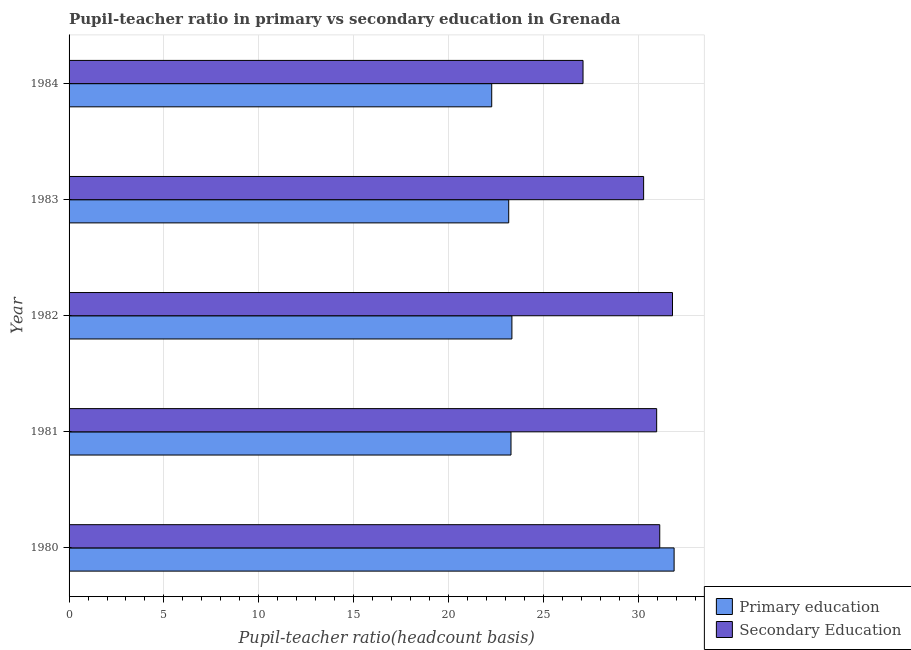Are the number of bars per tick equal to the number of legend labels?
Offer a very short reply. Yes. Are the number of bars on each tick of the Y-axis equal?
Offer a terse response. Yes. In how many cases, is the number of bars for a given year not equal to the number of legend labels?
Provide a short and direct response. 0. What is the pupil-teacher ratio in primary education in 1982?
Ensure brevity in your answer.  23.34. Across all years, what is the maximum pupil teacher ratio on secondary education?
Keep it short and to the point. 31.81. Across all years, what is the minimum pupil teacher ratio on secondary education?
Provide a short and direct response. 27.09. In which year was the pupil-teacher ratio in primary education minimum?
Provide a succinct answer. 1984. What is the total pupil teacher ratio on secondary education in the graph?
Your answer should be very brief. 151.29. What is the difference between the pupil-teacher ratio in primary education in 1983 and that in 1984?
Your answer should be very brief. 0.9. What is the difference between the pupil-teacher ratio in primary education in 1984 and the pupil teacher ratio on secondary education in 1983?
Your answer should be compact. -8.01. What is the average pupil teacher ratio on secondary education per year?
Give a very brief answer. 30.26. In the year 1984, what is the difference between the pupil teacher ratio on secondary education and pupil-teacher ratio in primary education?
Provide a short and direct response. 4.81. What is the ratio of the pupil teacher ratio on secondary education in 1982 to that in 1984?
Make the answer very short. 1.17. Is the pupil-teacher ratio in primary education in 1982 less than that in 1983?
Your answer should be very brief. No. What is the difference between the highest and the second highest pupil teacher ratio on secondary education?
Your answer should be compact. 0.67. What is the difference between the highest and the lowest pupil-teacher ratio in primary education?
Your answer should be compact. 9.61. In how many years, is the pupil teacher ratio on secondary education greater than the average pupil teacher ratio on secondary education taken over all years?
Ensure brevity in your answer.  4. What does the 2nd bar from the top in 1983 represents?
Give a very brief answer. Primary education. How many bars are there?
Your answer should be very brief. 10. Are all the bars in the graph horizontal?
Your response must be concise. Yes. How many years are there in the graph?
Provide a short and direct response. 5. What is the difference between two consecutive major ticks on the X-axis?
Offer a terse response. 5. Are the values on the major ticks of X-axis written in scientific E-notation?
Provide a short and direct response. No. Does the graph contain any zero values?
Ensure brevity in your answer.  No. Does the graph contain grids?
Your response must be concise. Yes. Where does the legend appear in the graph?
Provide a short and direct response. Bottom right. How many legend labels are there?
Make the answer very short. 2. What is the title of the graph?
Provide a short and direct response. Pupil-teacher ratio in primary vs secondary education in Grenada. What is the label or title of the X-axis?
Provide a short and direct response. Pupil-teacher ratio(headcount basis). What is the label or title of the Y-axis?
Make the answer very short. Year. What is the Pupil-teacher ratio(headcount basis) in Primary education in 1980?
Your answer should be very brief. 31.89. What is the Pupil-teacher ratio(headcount basis) in Secondary Education in 1980?
Your answer should be compact. 31.13. What is the Pupil-teacher ratio(headcount basis) of Primary education in 1981?
Provide a short and direct response. 23.29. What is the Pupil-teacher ratio(headcount basis) in Secondary Education in 1981?
Your response must be concise. 30.97. What is the Pupil-teacher ratio(headcount basis) in Primary education in 1982?
Offer a terse response. 23.34. What is the Pupil-teacher ratio(headcount basis) of Secondary Education in 1982?
Ensure brevity in your answer.  31.81. What is the Pupil-teacher ratio(headcount basis) in Primary education in 1983?
Give a very brief answer. 23.17. What is the Pupil-teacher ratio(headcount basis) of Secondary Education in 1983?
Your answer should be compact. 30.28. What is the Pupil-teacher ratio(headcount basis) in Primary education in 1984?
Ensure brevity in your answer.  22.28. What is the Pupil-teacher ratio(headcount basis) of Secondary Education in 1984?
Offer a very short reply. 27.09. Across all years, what is the maximum Pupil-teacher ratio(headcount basis) in Primary education?
Give a very brief answer. 31.89. Across all years, what is the maximum Pupil-teacher ratio(headcount basis) in Secondary Education?
Offer a terse response. 31.81. Across all years, what is the minimum Pupil-teacher ratio(headcount basis) in Primary education?
Offer a very short reply. 22.28. Across all years, what is the minimum Pupil-teacher ratio(headcount basis) in Secondary Education?
Provide a succinct answer. 27.09. What is the total Pupil-teacher ratio(headcount basis) in Primary education in the graph?
Provide a succinct answer. 123.98. What is the total Pupil-teacher ratio(headcount basis) of Secondary Education in the graph?
Your answer should be very brief. 151.29. What is the difference between the Pupil-teacher ratio(headcount basis) in Primary education in 1980 and that in 1981?
Give a very brief answer. 8.6. What is the difference between the Pupil-teacher ratio(headcount basis) in Secondary Education in 1980 and that in 1981?
Keep it short and to the point. 0.16. What is the difference between the Pupil-teacher ratio(headcount basis) in Primary education in 1980 and that in 1982?
Your response must be concise. 8.55. What is the difference between the Pupil-teacher ratio(headcount basis) of Secondary Education in 1980 and that in 1982?
Offer a very short reply. -0.67. What is the difference between the Pupil-teacher ratio(headcount basis) in Primary education in 1980 and that in 1983?
Make the answer very short. 8.72. What is the difference between the Pupil-teacher ratio(headcount basis) in Secondary Education in 1980 and that in 1983?
Offer a very short reply. 0.85. What is the difference between the Pupil-teacher ratio(headcount basis) in Primary education in 1980 and that in 1984?
Your answer should be compact. 9.61. What is the difference between the Pupil-teacher ratio(headcount basis) of Secondary Education in 1980 and that in 1984?
Offer a very short reply. 4.04. What is the difference between the Pupil-teacher ratio(headcount basis) of Primary education in 1981 and that in 1982?
Keep it short and to the point. -0.05. What is the difference between the Pupil-teacher ratio(headcount basis) in Secondary Education in 1981 and that in 1982?
Make the answer very short. -0.83. What is the difference between the Pupil-teacher ratio(headcount basis) of Primary education in 1981 and that in 1983?
Provide a short and direct response. 0.12. What is the difference between the Pupil-teacher ratio(headcount basis) in Secondary Education in 1981 and that in 1983?
Offer a terse response. 0.69. What is the difference between the Pupil-teacher ratio(headcount basis) in Primary education in 1981 and that in 1984?
Offer a terse response. 1.02. What is the difference between the Pupil-teacher ratio(headcount basis) in Secondary Education in 1981 and that in 1984?
Offer a very short reply. 3.88. What is the difference between the Pupil-teacher ratio(headcount basis) of Primary education in 1982 and that in 1983?
Your response must be concise. 0.17. What is the difference between the Pupil-teacher ratio(headcount basis) of Secondary Education in 1982 and that in 1983?
Your answer should be compact. 1.52. What is the difference between the Pupil-teacher ratio(headcount basis) of Primary education in 1982 and that in 1984?
Provide a short and direct response. 1.06. What is the difference between the Pupil-teacher ratio(headcount basis) in Secondary Education in 1982 and that in 1984?
Your answer should be very brief. 4.72. What is the difference between the Pupil-teacher ratio(headcount basis) of Primary education in 1983 and that in 1984?
Offer a terse response. 0.9. What is the difference between the Pupil-teacher ratio(headcount basis) in Secondary Education in 1983 and that in 1984?
Offer a very short reply. 3.19. What is the difference between the Pupil-teacher ratio(headcount basis) in Primary education in 1980 and the Pupil-teacher ratio(headcount basis) in Secondary Education in 1981?
Make the answer very short. 0.92. What is the difference between the Pupil-teacher ratio(headcount basis) of Primary education in 1980 and the Pupil-teacher ratio(headcount basis) of Secondary Education in 1982?
Offer a very short reply. 0.09. What is the difference between the Pupil-teacher ratio(headcount basis) in Primary education in 1980 and the Pupil-teacher ratio(headcount basis) in Secondary Education in 1983?
Your answer should be compact. 1.61. What is the difference between the Pupil-teacher ratio(headcount basis) of Primary education in 1980 and the Pupil-teacher ratio(headcount basis) of Secondary Education in 1984?
Keep it short and to the point. 4.8. What is the difference between the Pupil-teacher ratio(headcount basis) of Primary education in 1981 and the Pupil-teacher ratio(headcount basis) of Secondary Education in 1982?
Provide a short and direct response. -8.51. What is the difference between the Pupil-teacher ratio(headcount basis) in Primary education in 1981 and the Pupil-teacher ratio(headcount basis) in Secondary Education in 1983?
Your answer should be very brief. -6.99. What is the difference between the Pupil-teacher ratio(headcount basis) in Primary education in 1981 and the Pupil-teacher ratio(headcount basis) in Secondary Education in 1984?
Your response must be concise. -3.8. What is the difference between the Pupil-teacher ratio(headcount basis) in Primary education in 1982 and the Pupil-teacher ratio(headcount basis) in Secondary Education in 1983?
Keep it short and to the point. -6.94. What is the difference between the Pupil-teacher ratio(headcount basis) in Primary education in 1982 and the Pupil-teacher ratio(headcount basis) in Secondary Education in 1984?
Keep it short and to the point. -3.75. What is the difference between the Pupil-teacher ratio(headcount basis) in Primary education in 1983 and the Pupil-teacher ratio(headcount basis) in Secondary Education in 1984?
Provide a short and direct response. -3.92. What is the average Pupil-teacher ratio(headcount basis) in Primary education per year?
Give a very brief answer. 24.8. What is the average Pupil-teacher ratio(headcount basis) in Secondary Education per year?
Provide a short and direct response. 30.26. In the year 1980, what is the difference between the Pupil-teacher ratio(headcount basis) of Primary education and Pupil-teacher ratio(headcount basis) of Secondary Education?
Provide a short and direct response. 0.76. In the year 1981, what is the difference between the Pupil-teacher ratio(headcount basis) in Primary education and Pupil-teacher ratio(headcount basis) in Secondary Education?
Provide a short and direct response. -7.68. In the year 1982, what is the difference between the Pupil-teacher ratio(headcount basis) in Primary education and Pupil-teacher ratio(headcount basis) in Secondary Education?
Your response must be concise. -8.47. In the year 1983, what is the difference between the Pupil-teacher ratio(headcount basis) of Primary education and Pupil-teacher ratio(headcount basis) of Secondary Education?
Ensure brevity in your answer.  -7.11. In the year 1984, what is the difference between the Pupil-teacher ratio(headcount basis) of Primary education and Pupil-teacher ratio(headcount basis) of Secondary Education?
Offer a terse response. -4.81. What is the ratio of the Pupil-teacher ratio(headcount basis) of Primary education in 1980 to that in 1981?
Your response must be concise. 1.37. What is the ratio of the Pupil-teacher ratio(headcount basis) of Secondary Education in 1980 to that in 1981?
Your response must be concise. 1.01. What is the ratio of the Pupil-teacher ratio(headcount basis) of Primary education in 1980 to that in 1982?
Offer a very short reply. 1.37. What is the ratio of the Pupil-teacher ratio(headcount basis) in Secondary Education in 1980 to that in 1982?
Your answer should be very brief. 0.98. What is the ratio of the Pupil-teacher ratio(headcount basis) of Primary education in 1980 to that in 1983?
Give a very brief answer. 1.38. What is the ratio of the Pupil-teacher ratio(headcount basis) of Secondary Education in 1980 to that in 1983?
Your answer should be very brief. 1.03. What is the ratio of the Pupil-teacher ratio(headcount basis) in Primary education in 1980 to that in 1984?
Keep it short and to the point. 1.43. What is the ratio of the Pupil-teacher ratio(headcount basis) in Secondary Education in 1980 to that in 1984?
Your response must be concise. 1.15. What is the ratio of the Pupil-teacher ratio(headcount basis) in Secondary Education in 1981 to that in 1982?
Your answer should be compact. 0.97. What is the ratio of the Pupil-teacher ratio(headcount basis) of Secondary Education in 1981 to that in 1983?
Give a very brief answer. 1.02. What is the ratio of the Pupil-teacher ratio(headcount basis) in Primary education in 1981 to that in 1984?
Ensure brevity in your answer.  1.05. What is the ratio of the Pupil-teacher ratio(headcount basis) of Secondary Education in 1981 to that in 1984?
Keep it short and to the point. 1.14. What is the ratio of the Pupil-teacher ratio(headcount basis) in Primary education in 1982 to that in 1983?
Offer a very short reply. 1.01. What is the ratio of the Pupil-teacher ratio(headcount basis) of Secondary Education in 1982 to that in 1983?
Offer a very short reply. 1.05. What is the ratio of the Pupil-teacher ratio(headcount basis) of Primary education in 1982 to that in 1984?
Give a very brief answer. 1.05. What is the ratio of the Pupil-teacher ratio(headcount basis) of Secondary Education in 1982 to that in 1984?
Provide a short and direct response. 1.17. What is the ratio of the Pupil-teacher ratio(headcount basis) of Primary education in 1983 to that in 1984?
Offer a very short reply. 1.04. What is the ratio of the Pupil-teacher ratio(headcount basis) in Secondary Education in 1983 to that in 1984?
Offer a terse response. 1.12. What is the difference between the highest and the second highest Pupil-teacher ratio(headcount basis) in Primary education?
Provide a short and direct response. 8.55. What is the difference between the highest and the second highest Pupil-teacher ratio(headcount basis) in Secondary Education?
Your answer should be very brief. 0.67. What is the difference between the highest and the lowest Pupil-teacher ratio(headcount basis) of Primary education?
Keep it short and to the point. 9.61. What is the difference between the highest and the lowest Pupil-teacher ratio(headcount basis) of Secondary Education?
Offer a very short reply. 4.72. 